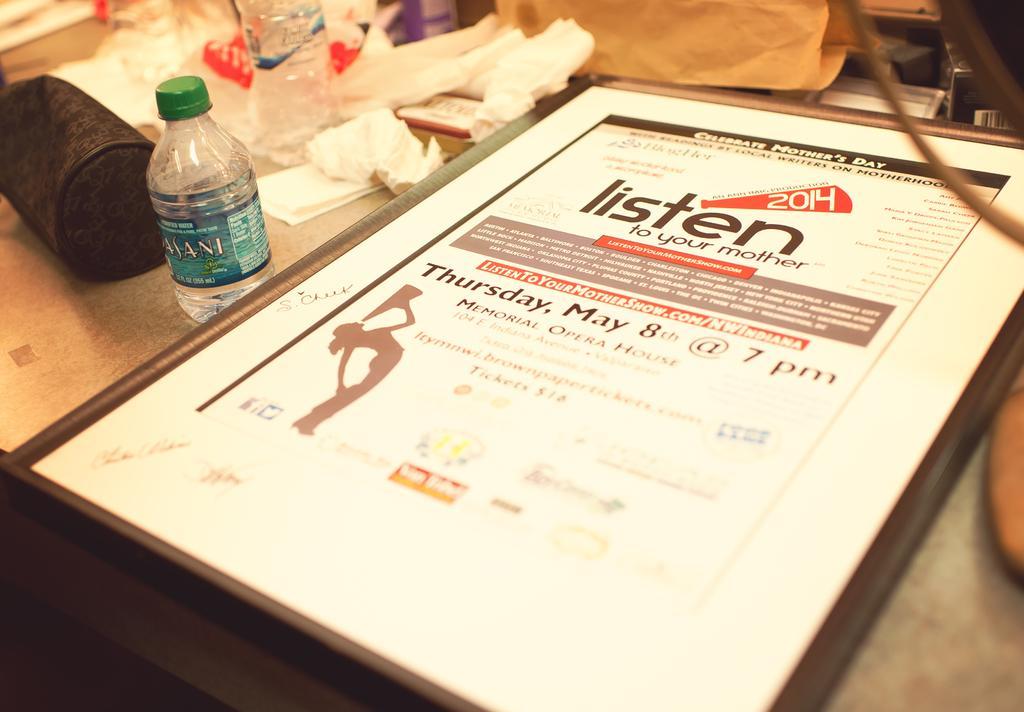In one or two sentences, can you explain what this image depicts? There is a table which has a invitation,water bottle and some other objects on it. 